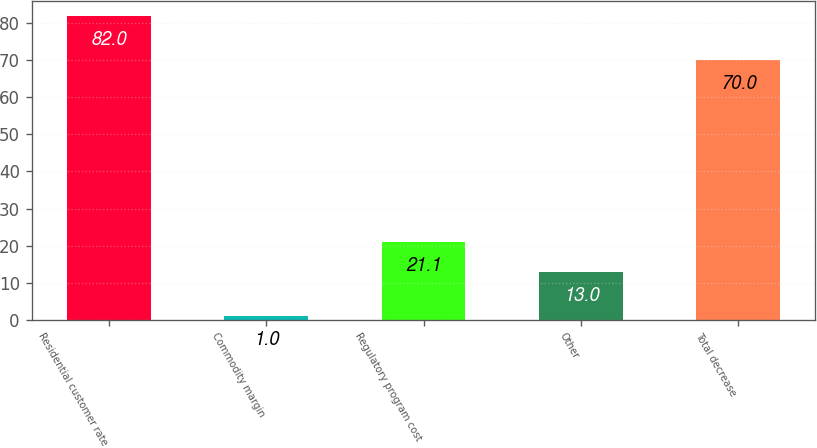<chart> <loc_0><loc_0><loc_500><loc_500><bar_chart><fcel>Residential customer rate<fcel>Commodity margin<fcel>Regulatory program cost<fcel>Other<fcel>Total decrease<nl><fcel>82<fcel>1<fcel>21.1<fcel>13<fcel>70<nl></chart> 